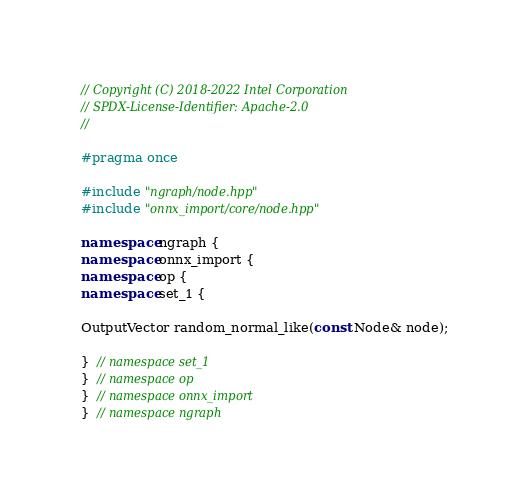<code> <loc_0><loc_0><loc_500><loc_500><_C++_>// Copyright (C) 2018-2022 Intel Corporation
// SPDX-License-Identifier: Apache-2.0
//

#pragma once

#include "ngraph/node.hpp"
#include "onnx_import/core/node.hpp"

namespace ngraph {
namespace onnx_import {
namespace op {
namespace set_1 {

OutputVector random_normal_like(const Node& node);

}  // namespace set_1
}  // namespace op
}  // namespace onnx_import
}  // namespace ngraph
</code> 